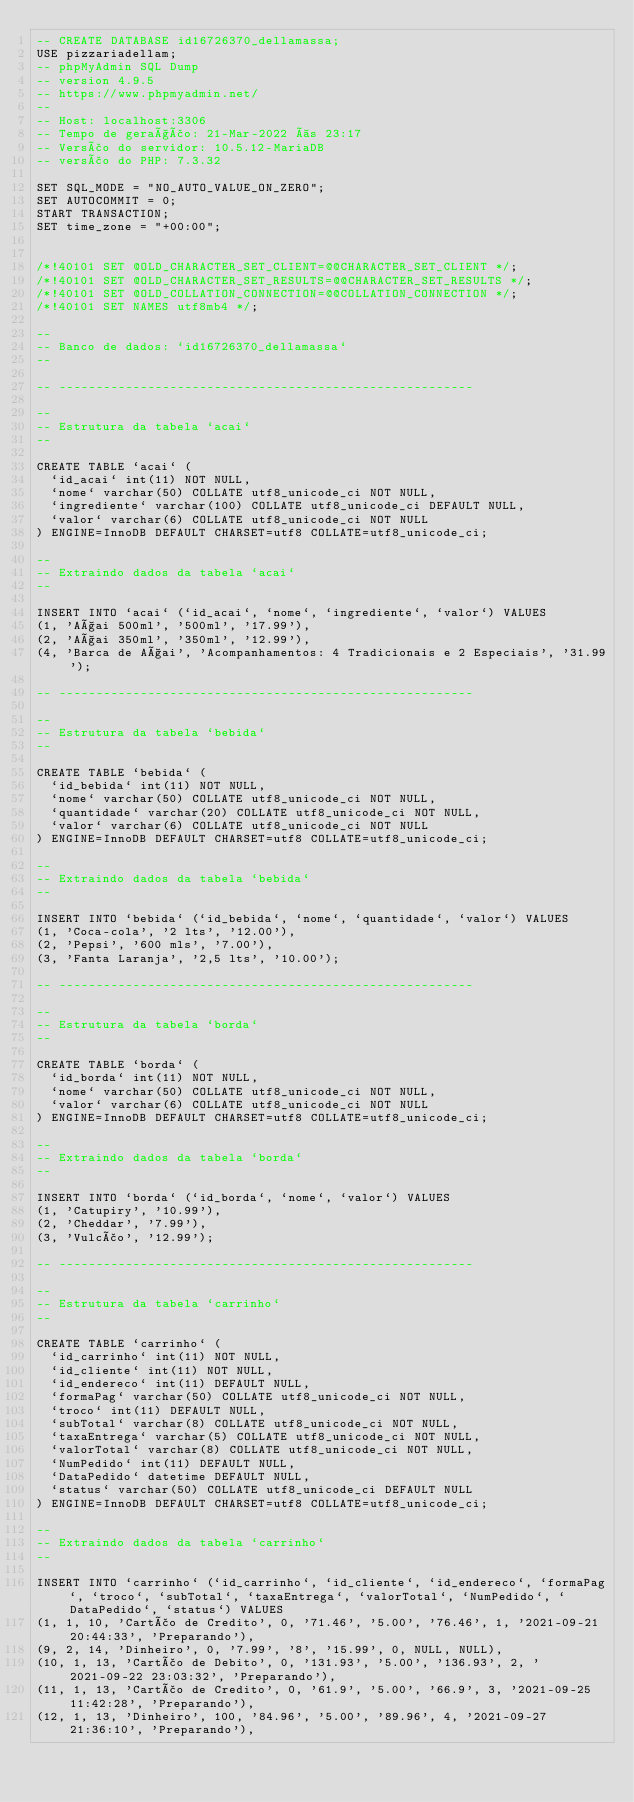<code> <loc_0><loc_0><loc_500><loc_500><_SQL_>-- CREATE DATABASE id16726370_dellamassa;
USE pizzariadellam;
-- phpMyAdmin SQL Dump
-- version 4.9.5
-- https://www.phpmyadmin.net/
--
-- Host: localhost:3306
-- Tempo de geração: 21-Mar-2022 às 23:17
-- Versão do servidor: 10.5.12-MariaDB
-- versão do PHP: 7.3.32

SET SQL_MODE = "NO_AUTO_VALUE_ON_ZERO";
SET AUTOCOMMIT = 0;
START TRANSACTION;
SET time_zone = "+00:00";


/*!40101 SET @OLD_CHARACTER_SET_CLIENT=@@CHARACTER_SET_CLIENT */;
/*!40101 SET @OLD_CHARACTER_SET_RESULTS=@@CHARACTER_SET_RESULTS */;
/*!40101 SET @OLD_COLLATION_CONNECTION=@@COLLATION_CONNECTION */;
/*!40101 SET NAMES utf8mb4 */;

--
-- Banco de dados: `id16726370_dellamassa`
--

-- --------------------------------------------------------

--
-- Estrutura da tabela `acai`
--

CREATE TABLE `acai` (
  `id_acai` int(11) NOT NULL,
  `nome` varchar(50) COLLATE utf8_unicode_ci NOT NULL,
  `ingrediente` varchar(100) COLLATE utf8_unicode_ci DEFAULT NULL,
  `valor` varchar(6) COLLATE utf8_unicode_ci NOT NULL
) ENGINE=InnoDB DEFAULT CHARSET=utf8 COLLATE=utf8_unicode_ci;

--
-- Extraindo dados da tabela `acai`
--

INSERT INTO `acai` (`id_acai`, `nome`, `ingrediente`, `valor`) VALUES
(1, 'Açai 500ml', '500ml', '17.99'),
(2, 'Açai 350ml', '350ml', '12.99'),
(4, 'Barca de Açai', 'Acompanhamentos: 4 Tradicionais e 2 Especiais', '31.99');

-- --------------------------------------------------------

--
-- Estrutura da tabela `bebida`
--

CREATE TABLE `bebida` (
  `id_bebida` int(11) NOT NULL,
  `nome` varchar(50) COLLATE utf8_unicode_ci NOT NULL,
  `quantidade` varchar(20) COLLATE utf8_unicode_ci NOT NULL,
  `valor` varchar(6) COLLATE utf8_unicode_ci NOT NULL
) ENGINE=InnoDB DEFAULT CHARSET=utf8 COLLATE=utf8_unicode_ci;

--
-- Extraindo dados da tabela `bebida`
--

INSERT INTO `bebida` (`id_bebida`, `nome`, `quantidade`, `valor`) VALUES
(1, 'Coca-cola', '2 lts', '12.00'),
(2, 'Pepsi', '600 mls', '7.00'),
(3, 'Fanta Laranja', '2,5 lts', '10.00');

-- --------------------------------------------------------

--
-- Estrutura da tabela `borda`
--

CREATE TABLE `borda` (
  `id_borda` int(11) NOT NULL,
  `nome` varchar(50) COLLATE utf8_unicode_ci NOT NULL,
  `valor` varchar(6) COLLATE utf8_unicode_ci NOT NULL
) ENGINE=InnoDB DEFAULT CHARSET=utf8 COLLATE=utf8_unicode_ci;

--
-- Extraindo dados da tabela `borda`
--

INSERT INTO `borda` (`id_borda`, `nome`, `valor`) VALUES
(1, 'Catupiry', '10.99'),
(2, 'Cheddar', '7.99'),
(3, 'Vulcão', '12.99');

-- --------------------------------------------------------

--
-- Estrutura da tabela `carrinho`
--

CREATE TABLE `carrinho` (
  `id_carrinho` int(11) NOT NULL,
  `id_cliente` int(11) NOT NULL,
  `id_endereco` int(11) DEFAULT NULL,
  `formaPag` varchar(50) COLLATE utf8_unicode_ci NOT NULL,
  `troco` int(11) DEFAULT NULL,
  `subTotal` varchar(8) COLLATE utf8_unicode_ci NOT NULL,
  `taxaEntrega` varchar(5) COLLATE utf8_unicode_ci NOT NULL,
  `valorTotal` varchar(8) COLLATE utf8_unicode_ci NOT NULL,
  `NumPedido` int(11) DEFAULT NULL,
  `DataPedido` datetime DEFAULT NULL,
  `status` varchar(50) COLLATE utf8_unicode_ci DEFAULT NULL
) ENGINE=InnoDB DEFAULT CHARSET=utf8 COLLATE=utf8_unicode_ci;

--
-- Extraindo dados da tabela `carrinho`
--

INSERT INTO `carrinho` (`id_carrinho`, `id_cliente`, `id_endereco`, `formaPag`, `troco`, `subTotal`, `taxaEntrega`, `valorTotal`, `NumPedido`, `DataPedido`, `status`) VALUES
(1, 1, 10, 'Cartão de Credito', 0, '71.46', '5.00', '76.46', 1, '2021-09-21 20:44:33', 'Preparando'),
(9, 2, 14, 'Dinheiro', 0, '7.99', '8', '15.99', 0, NULL, NULL),
(10, 1, 13, 'Cartão de Debito', 0, '131.93', '5.00', '136.93', 2, '2021-09-22 23:03:32', 'Preparando'),
(11, 1, 13, 'Cartão de Credito', 0, '61.9', '5.00', '66.9', 3, '2021-09-25 11:42:28', 'Preparando'),
(12, 1, 13, 'Dinheiro', 100, '84.96', '5.00', '89.96', 4, '2021-09-27 21:36:10', 'Preparando'),</code> 